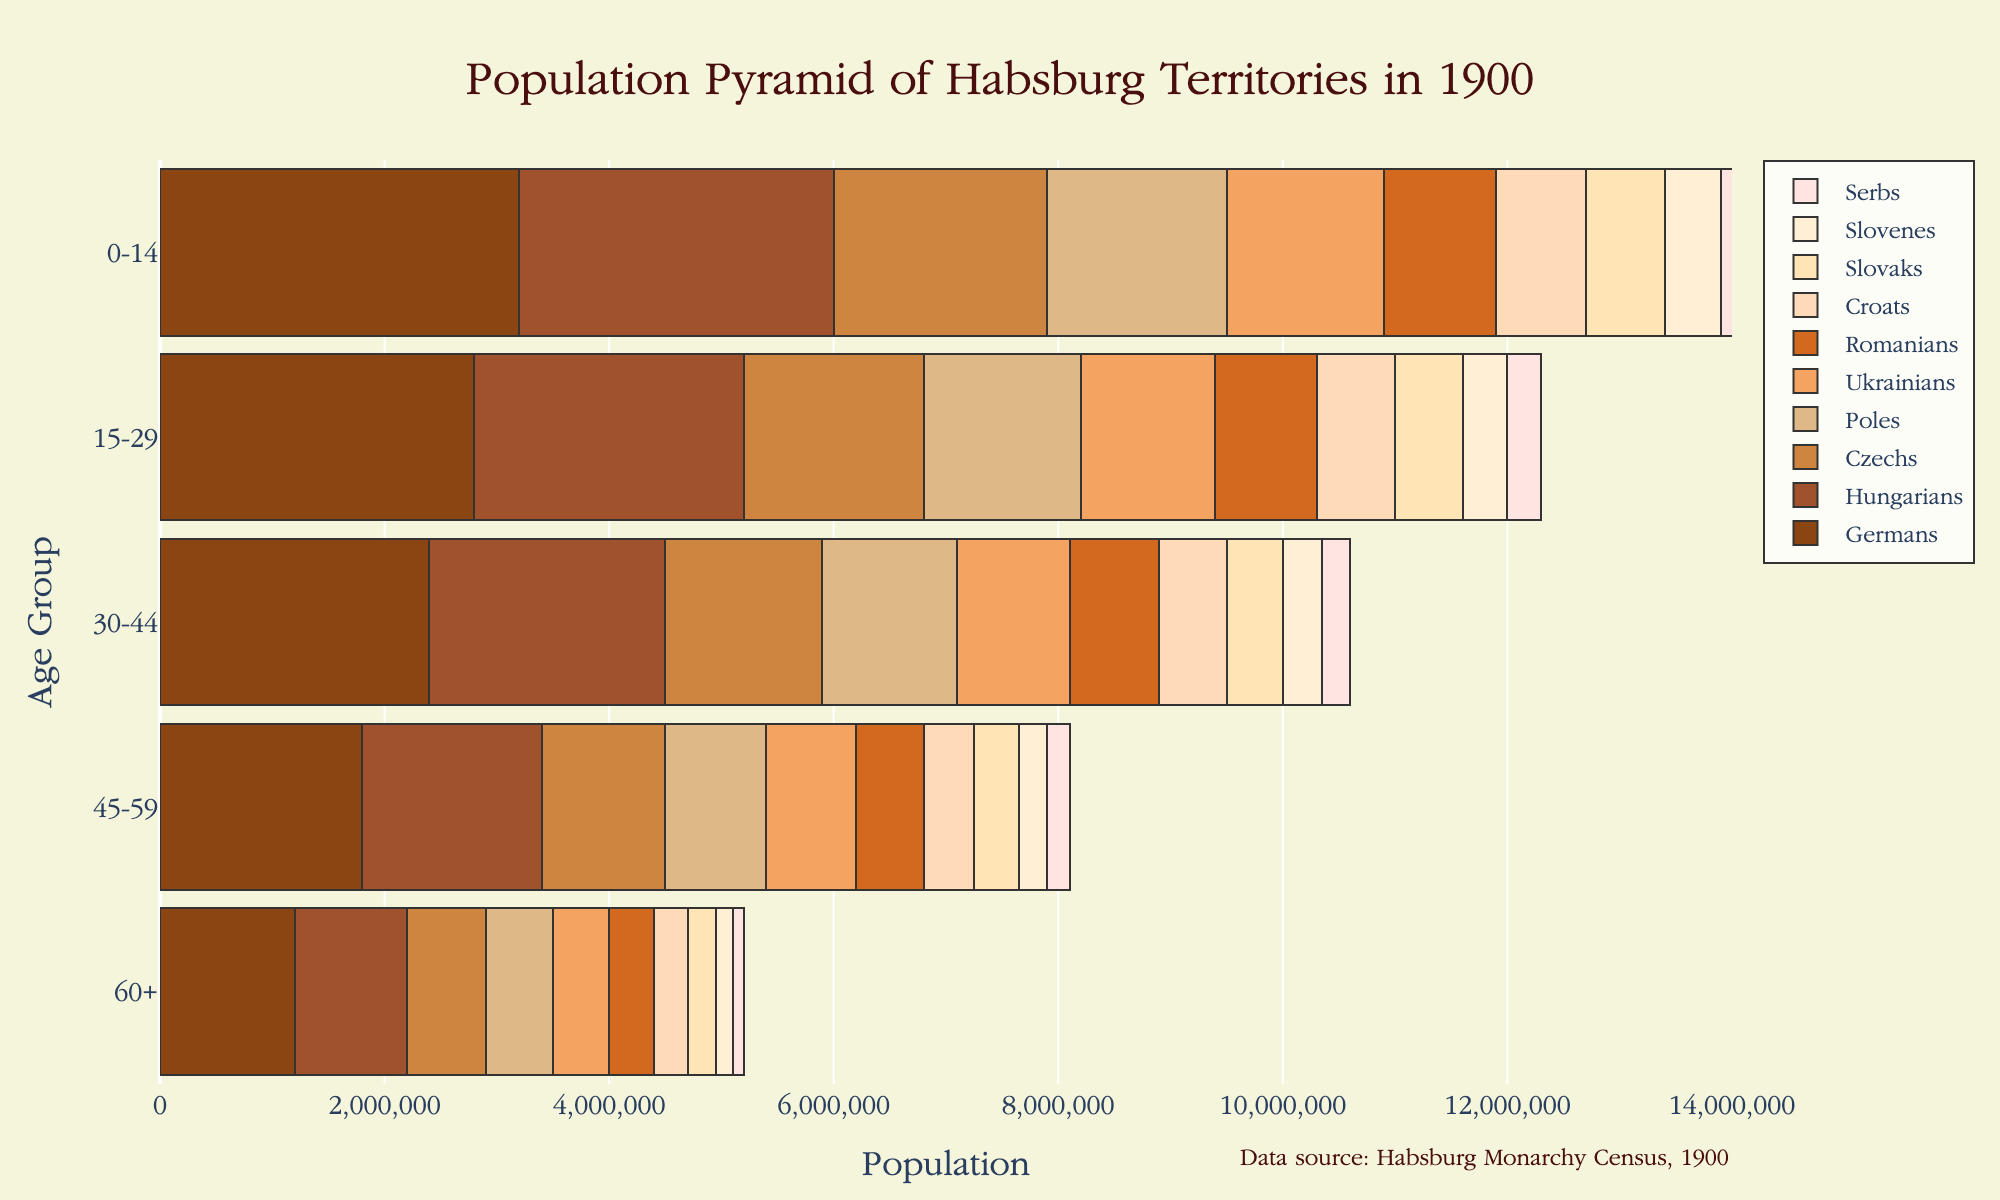what is the largest age group for Czechs? To determine the largest age group for Czechs, look for the bar that represents Czechs and check which age group has the longest bar. In this case, it's the 0-14 age group with 1,900,000 people.
Answer: 0-14 how many more Germans are there aged 15-29 compared to Romanians in the same age group? First, find the population of Germans aged 15-29 (2,800,000) and Romanians aged 15-29 (900,000). Then subtract the two numbers for the difference, 2,800,000 - 900,000 equals 1,900,000.
Answer: 1,900,000 which ethnic group has the smallest population in the 60+ age group? By checking the ending lengths of the bars in the 60+ age group, you can see that Serbs have the smallest population with 100,000 people.
Answer: Serbs What's the total population of Ukrainians across all age groups? Sum the populations of Ukrainians in all age groups: 1,400,000 (0-14) + 1,200,000 (15-29) + 1,000,000 (30-44) + 800,000 (45-59) + 500,000 (60+). The total is 4,900,000.
Answer: 4,900,000 How does the population of Hungarians aged 15-29 compare to that of Germans aged 30-44? Look for the population of Hungarians aged 15-29 and Germans aged 30-44. Hungarians aged 15-29 is 2,400,000, and Germans aged 30-44 is 2,400,000. Both populations are equal.
Answer: Equal What is the average population of Croats across all age groups? First, total the population of Croats across all age groups: 800,000 (0-14) + 700,000 (15-29) + 600,000 (30-44) + 450,000 (45-59) + 300,000 (60+). The sum is 2,850,000. Divide by the number of age groups (5) to get the average: 2,850,000 / 5 = 570,000.
Answer: 570,000 Which age group shows the most balanced population distribution among all ethnic groups? Check the similarity in bar lengths for an age group across different ethnic groups. The 60+ age group is most balanced as there aren't large disparities between the ethnic groups; most bars are relatively similar in length.
Answer: 60+ What age group has the highest total population across all ethnicities? For this, add the populations of all ethnicities in each age group and compare. The age group 0-14 sums to 10,400,000, 15-29 sums to 9,600,000, 30-44 sums to 8,550,000, 45-59 sums to 6,850,000, and 60+ sums to 4,700,000. Therefore, 0-14 has the highest total population.
Answer: 0-14 